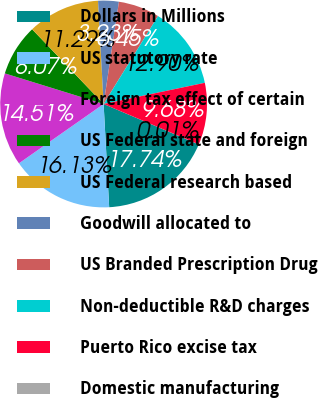Convert chart to OTSL. <chart><loc_0><loc_0><loc_500><loc_500><pie_chart><fcel>Dollars in Millions<fcel>US statutory rate<fcel>Foreign tax effect of certain<fcel>US Federal state and foreign<fcel>US Federal research based<fcel>Goodwill allocated to<fcel>US Branded Prescription Drug<fcel>Non-deductible R&D charges<fcel>Puerto Rico excise tax<fcel>Domestic manufacturing<nl><fcel>17.74%<fcel>16.13%<fcel>14.51%<fcel>8.07%<fcel>11.29%<fcel>3.23%<fcel>6.45%<fcel>12.9%<fcel>9.68%<fcel>0.01%<nl></chart> 